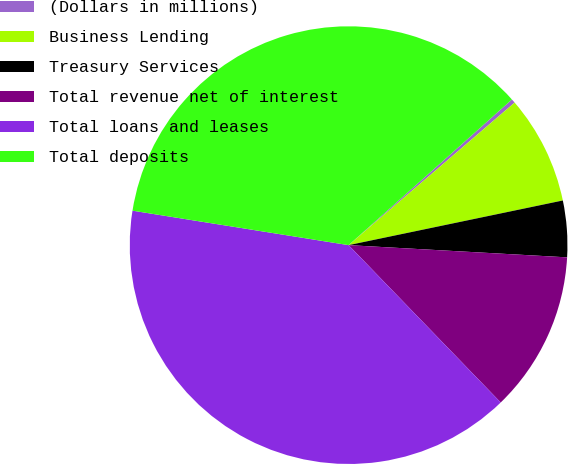Convert chart. <chart><loc_0><loc_0><loc_500><loc_500><pie_chart><fcel>(Dollars in millions)<fcel>Business Lending<fcel>Treasury Services<fcel>Total revenue net of interest<fcel>Total loans and leases<fcel>Total deposits<nl><fcel>0.3%<fcel>8.02%<fcel>4.16%<fcel>11.88%<fcel>39.75%<fcel>35.89%<nl></chart> 